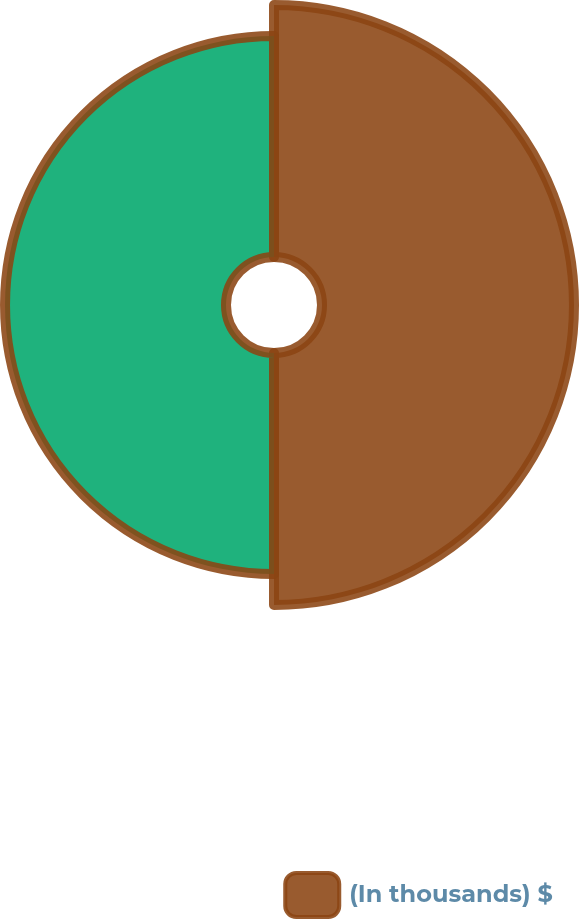<chart> <loc_0><loc_0><loc_500><loc_500><pie_chart><fcel>(In thousands) $<fcel>Unnamed: 1<nl><fcel>53.28%<fcel>46.72%<nl></chart> 